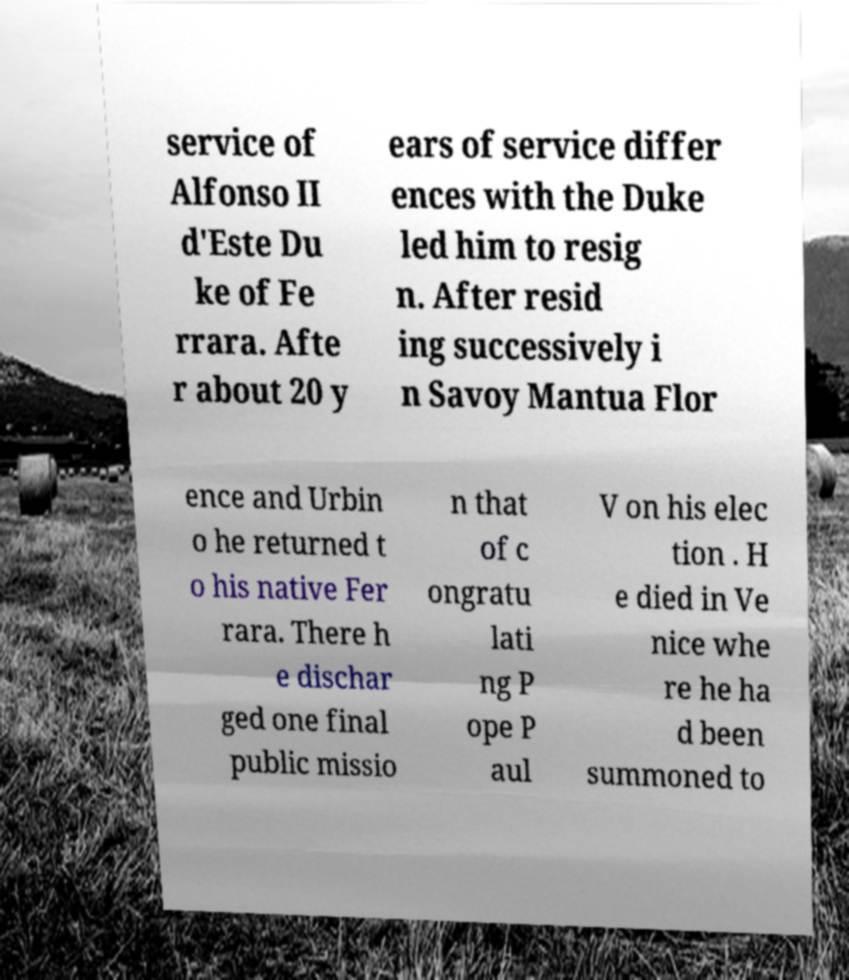Can you accurately transcribe the text from the provided image for me? service of Alfonso II d'Este Du ke of Fe rrara. Afte r about 20 y ears of service differ ences with the Duke led him to resig n. After resid ing successively i n Savoy Mantua Flor ence and Urbin o he returned t o his native Fer rara. There h e dischar ged one final public missio n that of c ongratu lati ng P ope P aul V on his elec tion . H e died in Ve nice whe re he ha d been summoned to 